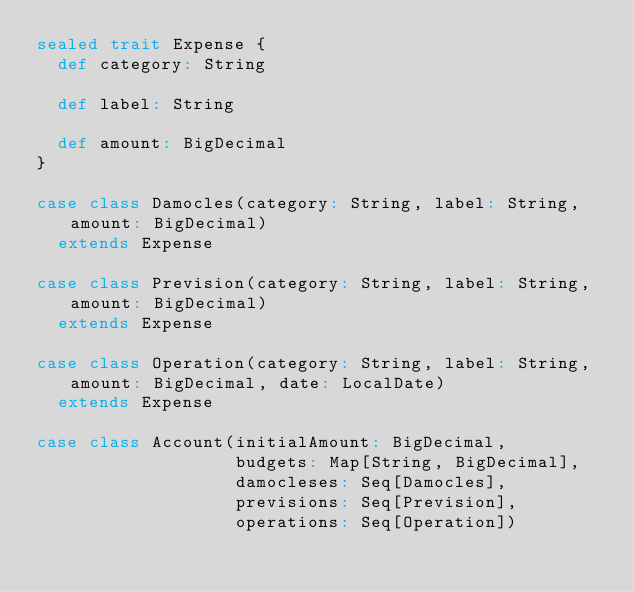<code> <loc_0><loc_0><loc_500><loc_500><_Scala_>sealed trait Expense {
  def category: String

  def label: String

  def amount: BigDecimal
}

case class Damocles(category: String, label: String, amount: BigDecimal)
  extends Expense

case class Prevision(category: String, label: String, amount: BigDecimal)
  extends Expense

case class Operation(category: String, label: String, amount: BigDecimal, date: LocalDate)
  extends Expense

case class Account(initialAmount: BigDecimal,
                   budgets: Map[String, BigDecimal],
                   damocleses: Seq[Damocles],
                   previsions: Seq[Prevision],
                   operations: Seq[Operation])

</code> 